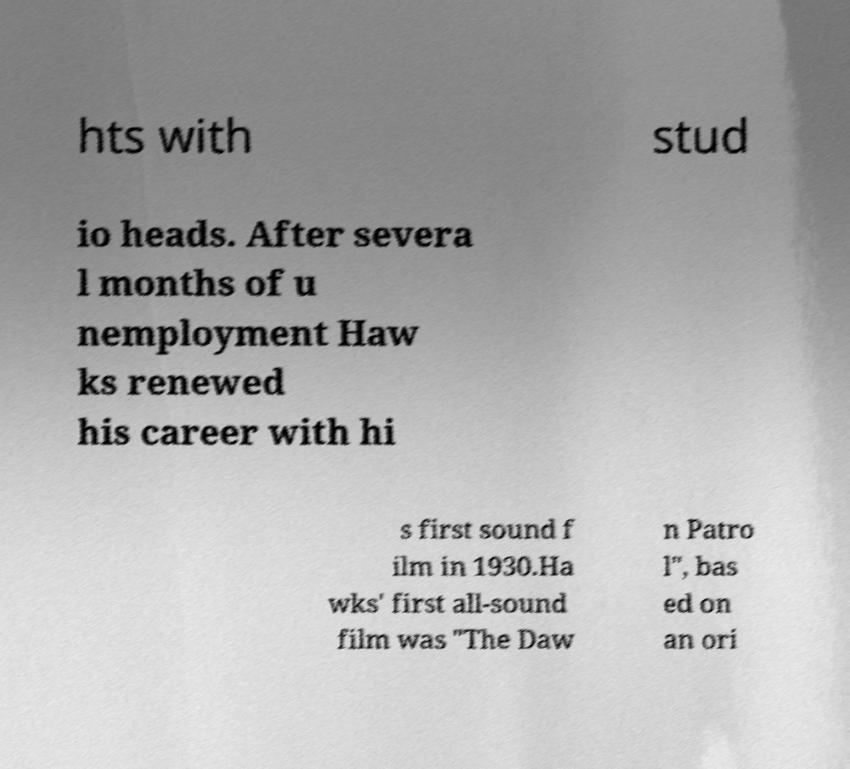Could you assist in decoding the text presented in this image and type it out clearly? hts with stud io heads. After severa l months of u nemployment Haw ks renewed his career with hi s first sound f ilm in 1930.Ha wks' first all-sound film was "The Daw n Patro l", bas ed on an ori 